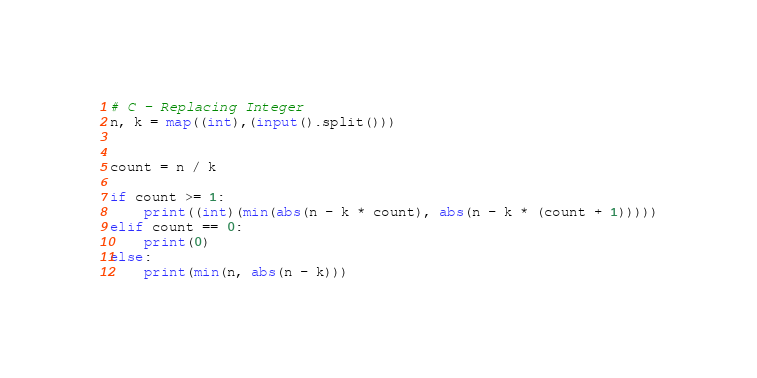Convert code to text. <code><loc_0><loc_0><loc_500><loc_500><_Python_># C - Replacing Integer
n, k = map((int),(input().split()))


count = n / k

if count >= 1:
    print((int)(min(abs(n - k * count), abs(n - k * (count + 1)))))
elif count == 0:
    print(0)
else:
    print(min(n, abs(n - k)))</code> 